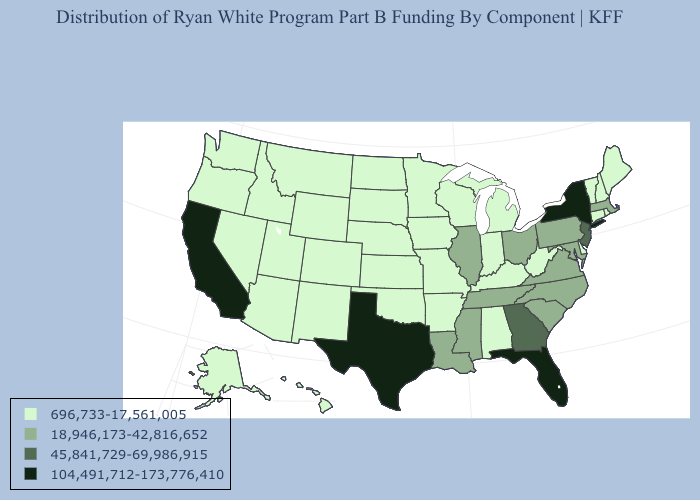What is the value of Connecticut?
Keep it brief. 696,733-17,561,005. What is the highest value in the USA?
Give a very brief answer. 104,491,712-173,776,410. Does Ohio have the lowest value in the MidWest?
Quick response, please. No. What is the lowest value in the Northeast?
Keep it brief. 696,733-17,561,005. Does Georgia have a higher value than Oklahoma?
Be succinct. Yes. Which states have the highest value in the USA?
Be succinct. California, Florida, New York, Texas. Name the states that have a value in the range 45,841,729-69,986,915?
Quick response, please. Georgia, New Jersey. Among the states that border North Carolina , which have the lowest value?
Be succinct. South Carolina, Tennessee, Virginia. What is the highest value in states that border Nevada?
Be succinct. 104,491,712-173,776,410. What is the value of Utah?
Quick response, please. 696,733-17,561,005. Which states have the lowest value in the USA?
Give a very brief answer. Alabama, Alaska, Arizona, Arkansas, Colorado, Connecticut, Delaware, Hawaii, Idaho, Indiana, Iowa, Kansas, Kentucky, Maine, Michigan, Minnesota, Missouri, Montana, Nebraska, Nevada, New Hampshire, New Mexico, North Dakota, Oklahoma, Oregon, Rhode Island, South Dakota, Utah, Vermont, Washington, West Virginia, Wisconsin, Wyoming. Which states hav the highest value in the MidWest?
Write a very short answer. Illinois, Ohio. What is the highest value in states that border Nevada?
Quick response, please. 104,491,712-173,776,410. Does the first symbol in the legend represent the smallest category?
Answer briefly. Yes. How many symbols are there in the legend?
Concise answer only. 4. 